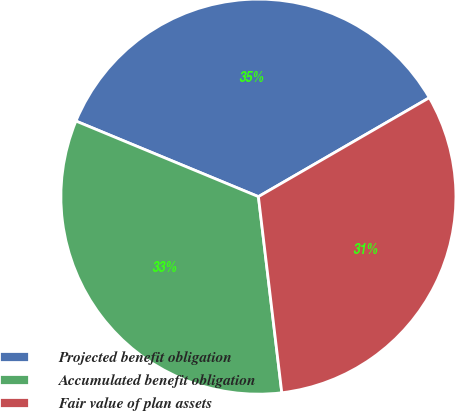Convert chart. <chart><loc_0><loc_0><loc_500><loc_500><pie_chart><fcel>Projected benefit obligation<fcel>Accumulated benefit obligation<fcel>Fair value of plan assets<nl><fcel>35.4%<fcel>33.14%<fcel>31.46%<nl></chart> 